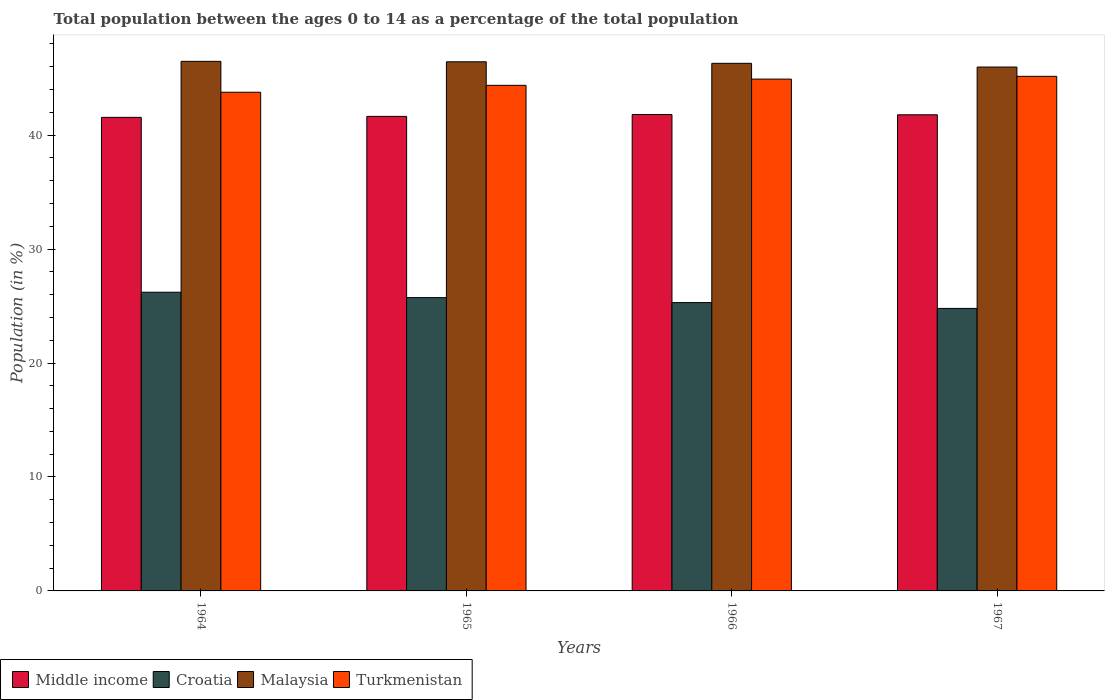How many different coloured bars are there?
Keep it short and to the point. 4. How many bars are there on the 2nd tick from the left?
Make the answer very short. 4. How many bars are there on the 3rd tick from the right?
Offer a very short reply. 4. What is the label of the 3rd group of bars from the left?
Provide a succinct answer. 1966. What is the percentage of the population ages 0 to 14 in Croatia in 1965?
Ensure brevity in your answer.  25.74. Across all years, what is the maximum percentage of the population ages 0 to 14 in Middle income?
Your answer should be compact. 41.81. Across all years, what is the minimum percentage of the population ages 0 to 14 in Croatia?
Provide a succinct answer. 24.79. In which year was the percentage of the population ages 0 to 14 in Malaysia maximum?
Offer a very short reply. 1964. In which year was the percentage of the population ages 0 to 14 in Middle income minimum?
Provide a short and direct response. 1964. What is the total percentage of the population ages 0 to 14 in Turkmenistan in the graph?
Ensure brevity in your answer.  178.21. What is the difference between the percentage of the population ages 0 to 14 in Malaysia in 1964 and that in 1967?
Give a very brief answer. 0.5. What is the difference between the percentage of the population ages 0 to 14 in Turkmenistan in 1966 and the percentage of the population ages 0 to 14 in Croatia in 1967?
Ensure brevity in your answer.  20.12. What is the average percentage of the population ages 0 to 14 in Middle income per year?
Offer a very short reply. 41.7. In the year 1967, what is the difference between the percentage of the population ages 0 to 14 in Turkmenistan and percentage of the population ages 0 to 14 in Malaysia?
Provide a succinct answer. -0.81. What is the ratio of the percentage of the population ages 0 to 14 in Turkmenistan in 1964 to that in 1967?
Keep it short and to the point. 0.97. Is the percentage of the population ages 0 to 14 in Malaysia in 1966 less than that in 1967?
Your answer should be very brief. No. Is the difference between the percentage of the population ages 0 to 14 in Turkmenistan in 1964 and 1965 greater than the difference between the percentage of the population ages 0 to 14 in Malaysia in 1964 and 1965?
Offer a terse response. No. What is the difference between the highest and the second highest percentage of the population ages 0 to 14 in Turkmenistan?
Keep it short and to the point. 0.24. What is the difference between the highest and the lowest percentage of the population ages 0 to 14 in Malaysia?
Provide a short and direct response. 0.5. Is the sum of the percentage of the population ages 0 to 14 in Croatia in 1964 and 1965 greater than the maximum percentage of the population ages 0 to 14 in Turkmenistan across all years?
Your response must be concise. Yes. What does the 2nd bar from the left in 1967 represents?
Your answer should be compact. Croatia. What does the 2nd bar from the right in 1966 represents?
Give a very brief answer. Malaysia. Is it the case that in every year, the sum of the percentage of the population ages 0 to 14 in Middle income and percentage of the population ages 0 to 14 in Croatia is greater than the percentage of the population ages 0 to 14 in Turkmenistan?
Offer a terse response. Yes. How many bars are there?
Your answer should be very brief. 16. Are all the bars in the graph horizontal?
Your answer should be very brief. No. How many years are there in the graph?
Offer a terse response. 4. What is the difference between two consecutive major ticks on the Y-axis?
Keep it short and to the point. 10. Are the values on the major ticks of Y-axis written in scientific E-notation?
Your response must be concise. No. Does the graph contain any zero values?
Your response must be concise. No. Does the graph contain grids?
Offer a very short reply. No. How many legend labels are there?
Provide a short and direct response. 4. How are the legend labels stacked?
Ensure brevity in your answer.  Horizontal. What is the title of the graph?
Offer a very short reply. Total population between the ages 0 to 14 as a percentage of the total population. What is the label or title of the X-axis?
Provide a short and direct response. Years. What is the Population (in %) in Middle income in 1964?
Provide a short and direct response. 41.56. What is the Population (in %) in Croatia in 1964?
Your answer should be very brief. 26.21. What is the Population (in %) of Malaysia in 1964?
Your answer should be very brief. 46.47. What is the Population (in %) of Turkmenistan in 1964?
Your answer should be very brief. 43.76. What is the Population (in %) in Middle income in 1965?
Keep it short and to the point. 41.64. What is the Population (in %) in Croatia in 1965?
Your response must be concise. 25.74. What is the Population (in %) of Malaysia in 1965?
Your answer should be compact. 46.44. What is the Population (in %) of Turkmenistan in 1965?
Your answer should be very brief. 44.37. What is the Population (in %) in Middle income in 1966?
Provide a short and direct response. 41.81. What is the Population (in %) in Croatia in 1966?
Make the answer very short. 25.3. What is the Population (in %) of Malaysia in 1966?
Ensure brevity in your answer.  46.3. What is the Population (in %) of Turkmenistan in 1966?
Your response must be concise. 44.92. What is the Population (in %) of Middle income in 1967?
Offer a very short reply. 41.78. What is the Population (in %) of Croatia in 1967?
Make the answer very short. 24.79. What is the Population (in %) of Malaysia in 1967?
Your answer should be very brief. 45.97. What is the Population (in %) in Turkmenistan in 1967?
Give a very brief answer. 45.16. Across all years, what is the maximum Population (in %) of Middle income?
Offer a terse response. 41.81. Across all years, what is the maximum Population (in %) of Croatia?
Provide a short and direct response. 26.21. Across all years, what is the maximum Population (in %) in Malaysia?
Your response must be concise. 46.47. Across all years, what is the maximum Population (in %) of Turkmenistan?
Your answer should be very brief. 45.16. Across all years, what is the minimum Population (in %) of Middle income?
Give a very brief answer. 41.56. Across all years, what is the minimum Population (in %) of Croatia?
Your answer should be very brief. 24.79. Across all years, what is the minimum Population (in %) of Malaysia?
Provide a short and direct response. 45.97. Across all years, what is the minimum Population (in %) of Turkmenistan?
Your response must be concise. 43.76. What is the total Population (in %) of Middle income in the graph?
Keep it short and to the point. 166.8. What is the total Population (in %) in Croatia in the graph?
Make the answer very short. 102.05. What is the total Population (in %) in Malaysia in the graph?
Your response must be concise. 185.19. What is the total Population (in %) of Turkmenistan in the graph?
Your answer should be compact. 178.21. What is the difference between the Population (in %) in Middle income in 1964 and that in 1965?
Offer a very short reply. -0.09. What is the difference between the Population (in %) in Croatia in 1964 and that in 1965?
Keep it short and to the point. 0.47. What is the difference between the Population (in %) of Malaysia in 1964 and that in 1965?
Your answer should be very brief. 0.04. What is the difference between the Population (in %) of Turkmenistan in 1964 and that in 1965?
Ensure brevity in your answer.  -0.61. What is the difference between the Population (in %) of Middle income in 1964 and that in 1966?
Give a very brief answer. -0.25. What is the difference between the Population (in %) in Croatia in 1964 and that in 1966?
Offer a terse response. 0.91. What is the difference between the Population (in %) of Malaysia in 1964 and that in 1966?
Provide a short and direct response. 0.17. What is the difference between the Population (in %) of Turkmenistan in 1964 and that in 1966?
Provide a succinct answer. -1.15. What is the difference between the Population (in %) in Middle income in 1964 and that in 1967?
Provide a short and direct response. -0.23. What is the difference between the Population (in %) of Croatia in 1964 and that in 1967?
Offer a very short reply. 1.42. What is the difference between the Population (in %) in Malaysia in 1964 and that in 1967?
Your response must be concise. 0.5. What is the difference between the Population (in %) in Turkmenistan in 1964 and that in 1967?
Provide a succinct answer. -1.4. What is the difference between the Population (in %) in Middle income in 1965 and that in 1966?
Ensure brevity in your answer.  -0.17. What is the difference between the Population (in %) of Croatia in 1965 and that in 1966?
Give a very brief answer. 0.44. What is the difference between the Population (in %) of Malaysia in 1965 and that in 1966?
Your answer should be compact. 0.13. What is the difference between the Population (in %) in Turkmenistan in 1965 and that in 1966?
Your response must be concise. -0.55. What is the difference between the Population (in %) of Middle income in 1965 and that in 1967?
Provide a succinct answer. -0.14. What is the difference between the Population (in %) of Croatia in 1965 and that in 1967?
Offer a terse response. 0.95. What is the difference between the Population (in %) in Malaysia in 1965 and that in 1967?
Provide a short and direct response. 0.46. What is the difference between the Population (in %) of Turkmenistan in 1965 and that in 1967?
Offer a very short reply. -0.79. What is the difference between the Population (in %) of Middle income in 1966 and that in 1967?
Provide a short and direct response. 0.03. What is the difference between the Population (in %) of Croatia in 1966 and that in 1967?
Offer a very short reply. 0.51. What is the difference between the Population (in %) of Malaysia in 1966 and that in 1967?
Your answer should be very brief. 0.33. What is the difference between the Population (in %) of Turkmenistan in 1966 and that in 1967?
Your answer should be very brief. -0.24. What is the difference between the Population (in %) in Middle income in 1964 and the Population (in %) in Croatia in 1965?
Your response must be concise. 15.82. What is the difference between the Population (in %) of Middle income in 1964 and the Population (in %) of Malaysia in 1965?
Your response must be concise. -4.88. What is the difference between the Population (in %) in Middle income in 1964 and the Population (in %) in Turkmenistan in 1965?
Keep it short and to the point. -2.81. What is the difference between the Population (in %) of Croatia in 1964 and the Population (in %) of Malaysia in 1965?
Offer a terse response. -20.22. What is the difference between the Population (in %) of Croatia in 1964 and the Population (in %) of Turkmenistan in 1965?
Provide a short and direct response. -18.16. What is the difference between the Population (in %) of Malaysia in 1964 and the Population (in %) of Turkmenistan in 1965?
Give a very brief answer. 2.1. What is the difference between the Population (in %) of Middle income in 1964 and the Population (in %) of Croatia in 1966?
Offer a very short reply. 16.25. What is the difference between the Population (in %) in Middle income in 1964 and the Population (in %) in Malaysia in 1966?
Offer a terse response. -4.74. What is the difference between the Population (in %) of Middle income in 1964 and the Population (in %) of Turkmenistan in 1966?
Offer a very short reply. -3.36. What is the difference between the Population (in %) of Croatia in 1964 and the Population (in %) of Malaysia in 1966?
Keep it short and to the point. -20.09. What is the difference between the Population (in %) in Croatia in 1964 and the Population (in %) in Turkmenistan in 1966?
Keep it short and to the point. -18.7. What is the difference between the Population (in %) of Malaysia in 1964 and the Population (in %) of Turkmenistan in 1966?
Your answer should be compact. 1.56. What is the difference between the Population (in %) of Middle income in 1964 and the Population (in %) of Croatia in 1967?
Give a very brief answer. 16.77. What is the difference between the Population (in %) of Middle income in 1964 and the Population (in %) of Malaysia in 1967?
Your response must be concise. -4.42. What is the difference between the Population (in %) of Middle income in 1964 and the Population (in %) of Turkmenistan in 1967?
Offer a very short reply. -3.6. What is the difference between the Population (in %) in Croatia in 1964 and the Population (in %) in Malaysia in 1967?
Offer a terse response. -19.76. What is the difference between the Population (in %) in Croatia in 1964 and the Population (in %) in Turkmenistan in 1967?
Make the answer very short. -18.95. What is the difference between the Population (in %) in Malaysia in 1964 and the Population (in %) in Turkmenistan in 1967?
Give a very brief answer. 1.31. What is the difference between the Population (in %) in Middle income in 1965 and the Population (in %) in Croatia in 1966?
Keep it short and to the point. 16.34. What is the difference between the Population (in %) of Middle income in 1965 and the Population (in %) of Malaysia in 1966?
Make the answer very short. -4.66. What is the difference between the Population (in %) in Middle income in 1965 and the Population (in %) in Turkmenistan in 1966?
Your answer should be compact. -3.27. What is the difference between the Population (in %) of Croatia in 1965 and the Population (in %) of Malaysia in 1966?
Your answer should be compact. -20.56. What is the difference between the Population (in %) of Croatia in 1965 and the Population (in %) of Turkmenistan in 1966?
Make the answer very short. -19.17. What is the difference between the Population (in %) in Malaysia in 1965 and the Population (in %) in Turkmenistan in 1966?
Ensure brevity in your answer.  1.52. What is the difference between the Population (in %) of Middle income in 1965 and the Population (in %) of Croatia in 1967?
Offer a very short reply. 16.85. What is the difference between the Population (in %) in Middle income in 1965 and the Population (in %) in Malaysia in 1967?
Your answer should be very brief. -4.33. What is the difference between the Population (in %) of Middle income in 1965 and the Population (in %) of Turkmenistan in 1967?
Provide a succinct answer. -3.52. What is the difference between the Population (in %) of Croatia in 1965 and the Population (in %) of Malaysia in 1967?
Your answer should be compact. -20.23. What is the difference between the Population (in %) of Croatia in 1965 and the Population (in %) of Turkmenistan in 1967?
Give a very brief answer. -19.42. What is the difference between the Population (in %) of Malaysia in 1965 and the Population (in %) of Turkmenistan in 1967?
Ensure brevity in your answer.  1.28. What is the difference between the Population (in %) of Middle income in 1966 and the Population (in %) of Croatia in 1967?
Ensure brevity in your answer.  17.02. What is the difference between the Population (in %) in Middle income in 1966 and the Population (in %) in Malaysia in 1967?
Offer a terse response. -4.16. What is the difference between the Population (in %) in Middle income in 1966 and the Population (in %) in Turkmenistan in 1967?
Keep it short and to the point. -3.35. What is the difference between the Population (in %) of Croatia in 1966 and the Population (in %) of Malaysia in 1967?
Provide a short and direct response. -20.67. What is the difference between the Population (in %) of Croatia in 1966 and the Population (in %) of Turkmenistan in 1967?
Offer a very short reply. -19.86. What is the difference between the Population (in %) in Malaysia in 1966 and the Population (in %) in Turkmenistan in 1967?
Your response must be concise. 1.14. What is the average Population (in %) of Middle income per year?
Make the answer very short. 41.7. What is the average Population (in %) in Croatia per year?
Your answer should be very brief. 25.51. What is the average Population (in %) of Malaysia per year?
Ensure brevity in your answer.  46.3. What is the average Population (in %) in Turkmenistan per year?
Make the answer very short. 44.55. In the year 1964, what is the difference between the Population (in %) of Middle income and Population (in %) of Croatia?
Provide a succinct answer. 15.35. In the year 1964, what is the difference between the Population (in %) of Middle income and Population (in %) of Malaysia?
Offer a very short reply. -4.92. In the year 1964, what is the difference between the Population (in %) in Middle income and Population (in %) in Turkmenistan?
Provide a succinct answer. -2.2. In the year 1964, what is the difference between the Population (in %) of Croatia and Population (in %) of Malaysia?
Your answer should be very brief. -20.26. In the year 1964, what is the difference between the Population (in %) of Croatia and Population (in %) of Turkmenistan?
Give a very brief answer. -17.55. In the year 1964, what is the difference between the Population (in %) of Malaysia and Population (in %) of Turkmenistan?
Give a very brief answer. 2.71. In the year 1965, what is the difference between the Population (in %) of Middle income and Population (in %) of Croatia?
Your response must be concise. 15.9. In the year 1965, what is the difference between the Population (in %) in Middle income and Population (in %) in Malaysia?
Offer a terse response. -4.79. In the year 1965, what is the difference between the Population (in %) in Middle income and Population (in %) in Turkmenistan?
Offer a terse response. -2.73. In the year 1965, what is the difference between the Population (in %) of Croatia and Population (in %) of Malaysia?
Offer a terse response. -20.69. In the year 1965, what is the difference between the Population (in %) of Croatia and Population (in %) of Turkmenistan?
Make the answer very short. -18.63. In the year 1965, what is the difference between the Population (in %) in Malaysia and Population (in %) in Turkmenistan?
Provide a succinct answer. 2.07. In the year 1966, what is the difference between the Population (in %) in Middle income and Population (in %) in Croatia?
Give a very brief answer. 16.51. In the year 1966, what is the difference between the Population (in %) of Middle income and Population (in %) of Malaysia?
Your response must be concise. -4.49. In the year 1966, what is the difference between the Population (in %) in Middle income and Population (in %) in Turkmenistan?
Your response must be concise. -3.11. In the year 1966, what is the difference between the Population (in %) in Croatia and Population (in %) in Malaysia?
Offer a very short reply. -21. In the year 1966, what is the difference between the Population (in %) in Croatia and Population (in %) in Turkmenistan?
Make the answer very short. -19.61. In the year 1966, what is the difference between the Population (in %) of Malaysia and Population (in %) of Turkmenistan?
Give a very brief answer. 1.39. In the year 1967, what is the difference between the Population (in %) in Middle income and Population (in %) in Croatia?
Make the answer very short. 16.99. In the year 1967, what is the difference between the Population (in %) of Middle income and Population (in %) of Malaysia?
Offer a terse response. -4.19. In the year 1967, what is the difference between the Population (in %) in Middle income and Population (in %) in Turkmenistan?
Ensure brevity in your answer.  -3.38. In the year 1967, what is the difference between the Population (in %) in Croatia and Population (in %) in Malaysia?
Your response must be concise. -21.18. In the year 1967, what is the difference between the Population (in %) of Croatia and Population (in %) of Turkmenistan?
Your answer should be compact. -20.37. In the year 1967, what is the difference between the Population (in %) in Malaysia and Population (in %) in Turkmenistan?
Your response must be concise. 0.81. What is the ratio of the Population (in %) in Middle income in 1964 to that in 1965?
Offer a terse response. 1. What is the ratio of the Population (in %) of Croatia in 1964 to that in 1965?
Offer a very short reply. 1.02. What is the ratio of the Population (in %) in Malaysia in 1964 to that in 1965?
Provide a short and direct response. 1. What is the ratio of the Population (in %) in Turkmenistan in 1964 to that in 1965?
Give a very brief answer. 0.99. What is the ratio of the Population (in %) of Middle income in 1964 to that in 1966?
Your response must be concise. 0.99. What is the ratio of the Population (in %) of Croatia in 1964 to that in 1966?
Your answer should be very brief. 1.04. What is the ratio of the Population (in %) of Malaysia in 1964 to that in 1966?
Your answer should be compact. 1. What is the ratio of the Population (in %) of Turkmenistan in 1964 to that in 1966?
Offer a very short reply. 0.97. What is the ratio of the Population (in %) in Croatia in 1964 to that in 1967?
Offer a very short reply. 1.06. What is the ratio of the Population (in %) of Malaysia in 1964 to that in 1967?
Your answer should be very brief. 1.01. What is the ratio of the Population (in %) in Croatia in 1965 to that in 1966?
Offer a very short reply. 1.02. What is the ratio of the Population (in %) in Turkmenistan in 1965 to that in 1966?
Offer a very short reply. 0.99. What is the ratio of the Population (in %) in Middle income in 1965 to that in 1967?
Give a very brief answer. 1. What is the ratio of the Population (in %) of Croatia in 1965 to that in 1967?
Your response must be concise. 1.04. What is the ratio of the Population (in %) in Turkmenistan in 1965 to that in 1967?
Provide a succinct answer. 0.98. What is the ratio of the Population (in %) in Middle income in 1966 to that in 1967?
Offer a very short reply. 1. What is the ratio of the Population (in %) in Croatia in 1966 to that in 1967?
Offer a terse response. 1.02. What is the ratio of the Population (in %) of Malaysia in 1966 to that in 1967?
Your answer should be very brief. 1.01. What is the difference between the highest and the second highest Population (in %) of Middle income?
Provide a succinct answer. 0.03. What is the difference between the highest and the second highest Population (in %) in Croatia?
Give a very brief answer. 0.47. What is the difference between the highest and the second highest Population (in %) in Malaysia?
Your answer should be compact. 0.04. What is the difference between the highest and the second highest Population (in %) of Turkmenistan?
Ensure brevity in your answer.  0.24. What is the difference between the highest and the lowest Population (in %) of Middle income?
Your answer should be very brief. 0.25. What is the difference between the highest and the lowest Population (in %) of Croatia?
Offer a terse response. 1.42. What is the difference between the highest and the lowest Population (in %) in Malaysia?
Your answer should be compact. 0.5. What is the difference between the highest and the lowest Population (in %) in Turkmenistan?
Ensure brevity in your answer.  1.4. 